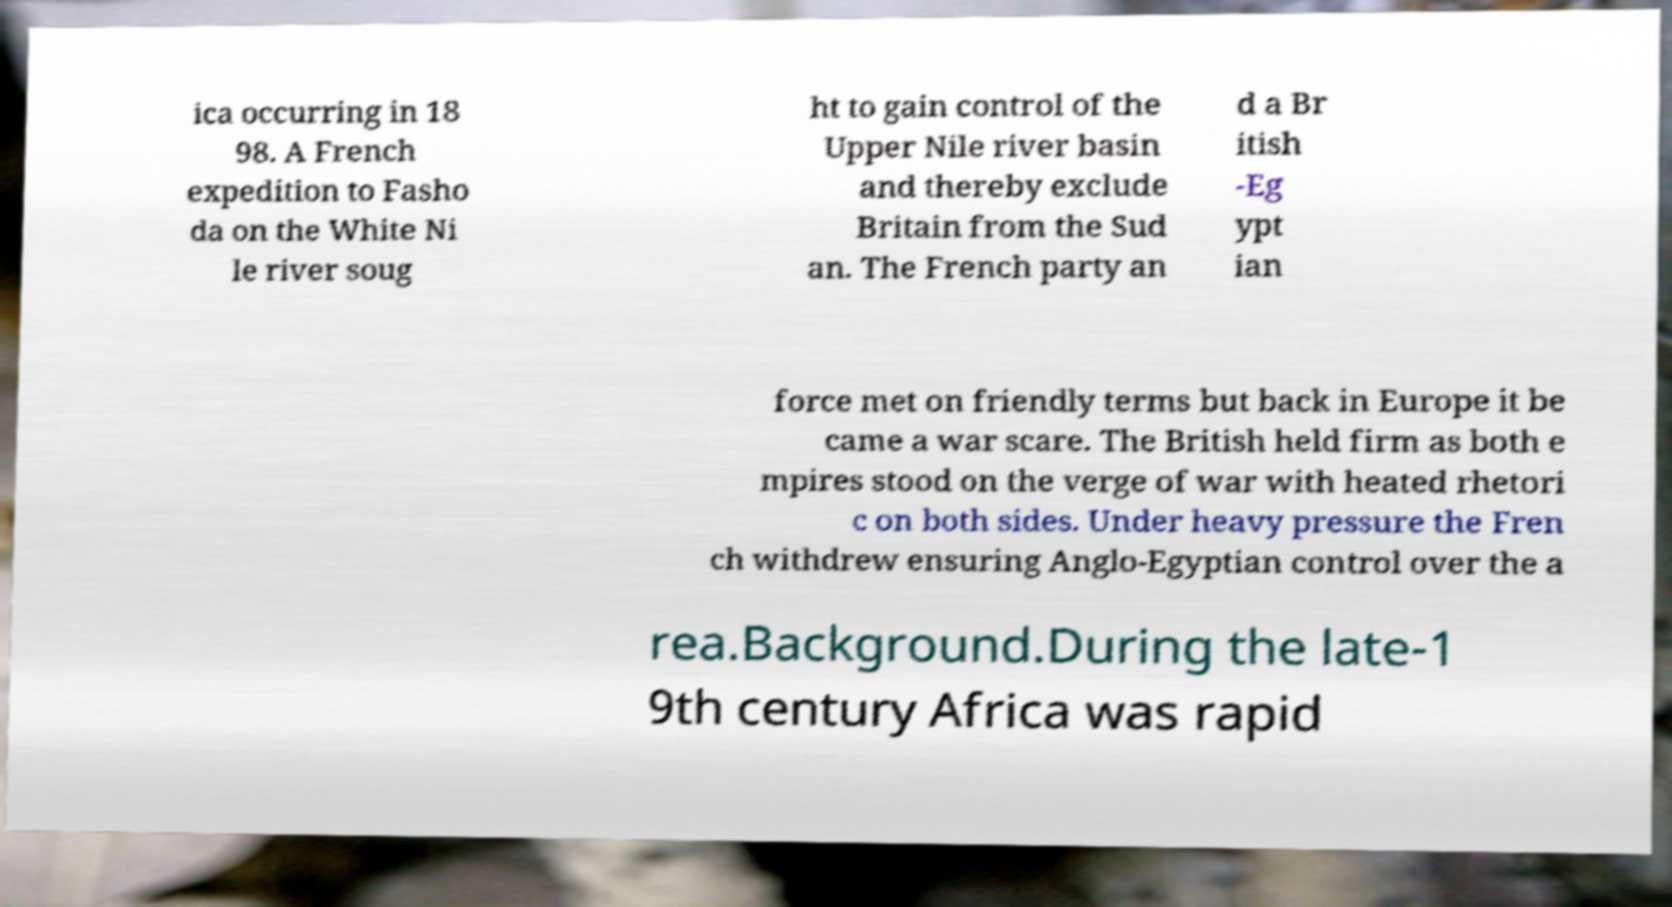I need the written content from this picture converted into text. Can you do that? ica occurring in 18 98. A French expedition to Fasho da on the White Ni le river soug ht to gain control of the Upper Nile river basin and thereby exclude Britain from the Sud an. The French party an d a Br itish -Eg ypt ian force met on friendly terms but back in Europe it be came a war scare. The British held firm as both e mpires stood on the verge of war with heated rhetori c on both sides. Under heavy pressure the Fren ch withdrew ensuring Anglo-Egyptian control over the a rea.Background.During the late-1 9th century Africa was rapid 